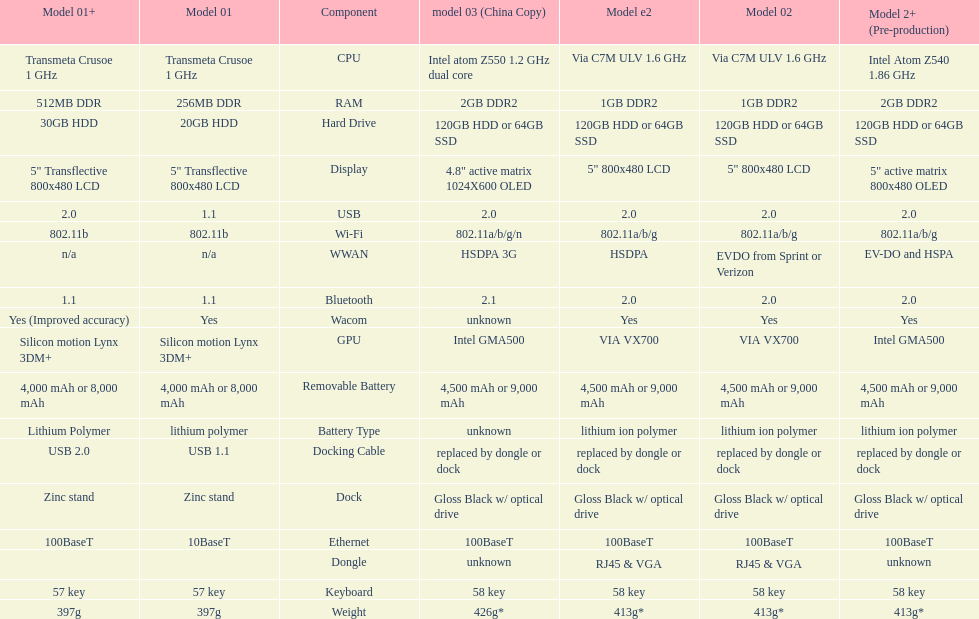How much more weight does the model 3 have over model 1? 29g. 